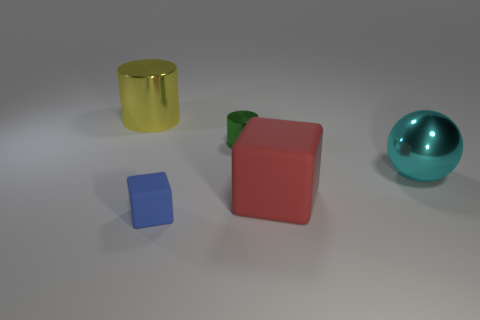There is a yellow cylinder that is made of the same material as the sphere; what is its size?
Keep it short and to the point. Large. What shape is the big shiny object that is to the left of the big shiny object that is in front of the cylinder that is right of the large metallic cylinder?
Your answer should be very brief. Cylinder. Are there the same number of shiny cylinders that are to the right of the green metallic object and yellow things?
Ensure brevity in your answer.  No. Is the shape of the green thing the same as the large yellow object?
Give a very brief answer. Yes. What number of things are small objects that are behind the tiny block or large red matte cubes?
Offer a very short reply. 2. Is the number of big shiny objects on the right side of the cyan metal sphere the same as the number of small blue blocks in front of the red object?
Keep it short and to the point. No. What number of other objects are there of the same shape as the cyan metal thing?
Ensure brevity in your answer.  0. Is the size of the metallic cylinder that is on the right side of the large cylinder the same as the rubber block that is in front of the red matte thing?
Ensure brevity in your answer.  Yes. How many balls are either small cyan metallic objects or cyan metallic objects?
Offer a very short reply. 1. How many matte things are either large purple cubes or big cylinders?
Offer a terse response. 0. 